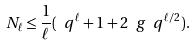<formula> <loc_0><loc_0><loc_500><loc_500>N _ { \ell } \leq \frac { 1 } { \ell } ( \ q ^ { \ell } + 1 + 2 \ g \ q ^ { \ell / 2 } ) .</formula> 